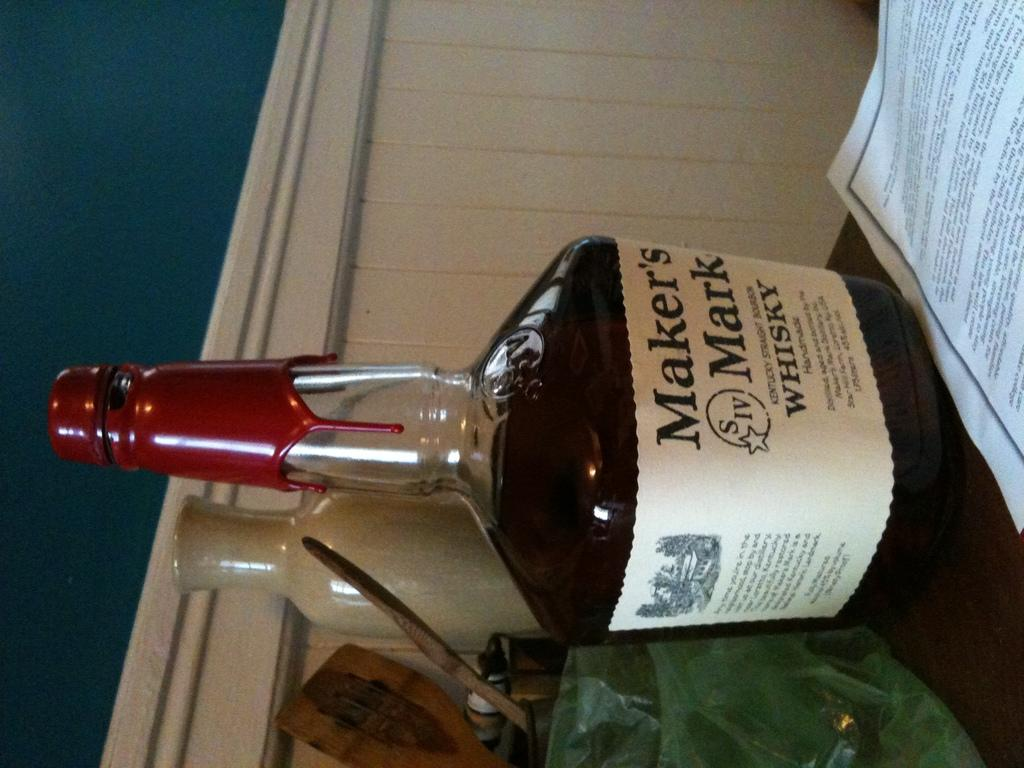<image>
Summarize the visual content of the image. A bottle of whisky has the name of Maker's Mark. 